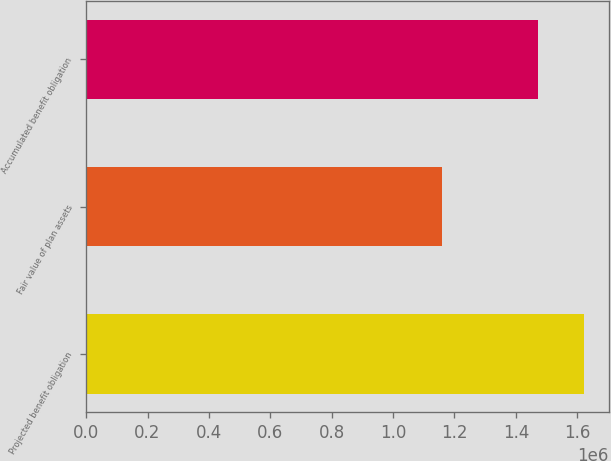Convert chart to OTSL. <chart><loc_0><loc_0><loc_500><loc_500><bar_chart><fcel>Projected benefit obligation<fcel>Fair value of plan assets<fcel>Accumulated benefit obligation<nl><fcel>1.621e+06<fcel>1.158e+06<fcel>1.472e+06<nl></chart> 